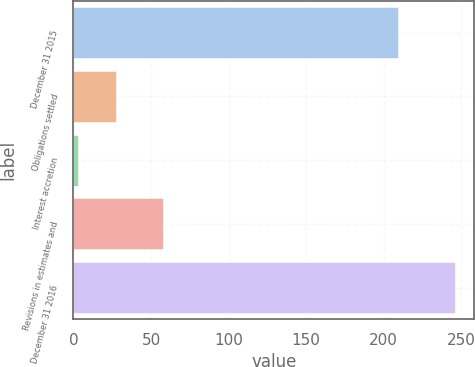Convert chart to OTSL. <chart><loc_0><loc_0><loc_500><loc_500><bar_chart><fcel>December 31 2015<fcel>Obligations settled<fcel>Interest accretion<fcel>Revisions in estimates and<fcel>December 31 2016<nl><fcel>209<fcel>27.3<fcel>3<fcel>58<fcel>246<nl></chart> 